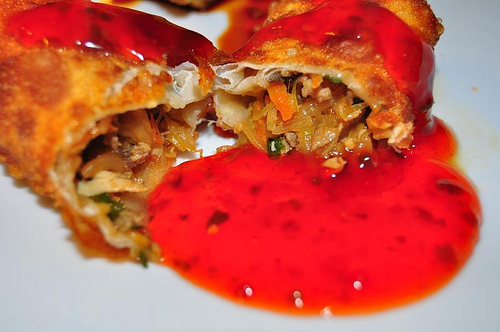<image>
Can you confirm if the sauce is under the eggroll? Yes. The sauce is positioned underneath the eggroll, with the eggroll above it in the vertical space. 